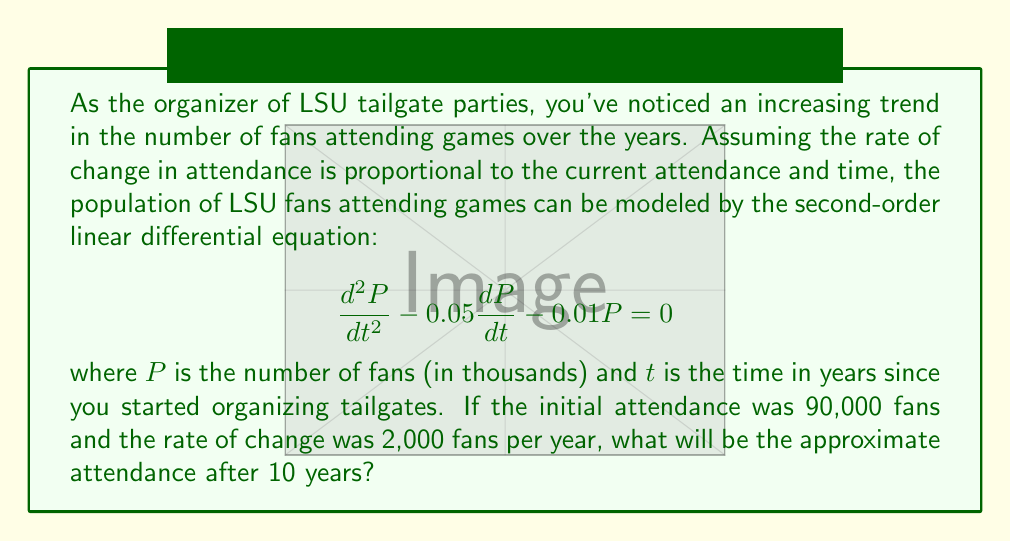Show me your answer to this math problem. To solve this problem, we need to follow these steps:

1) The general solution for this second-order linear differential equation is:

   $$P(t) = C_1e^{r_1t} + C_2e^{r_2t}$$

   where $r_1$ and $r_2$ are the roots of the characteristic equation.

2) The characteristic equation is:
   
   $$r^2 - 0.05r - 0.01 = 0$$

3) Solving this quadratic equation:
   
   $$r = \frac{0.05 \pm \sqrt{0.0025 + 0.04}}{2} = \frac{0.05 \pm 0.2}{2}$$

   $$r_1 = 0.125 \text{ and } r_2 = -0.075$$

4) Therefore, the general solution is:

   $$P(t) = C_1e^{0.125t} + C_2e^{-0.075t}$$

5) Now we use the initial conditions to find $C_1$ and $C_2$:
   
   At $t=0$, $P(0) = 90$ (remember, $P$ is in thousands)
   $$90 = C_1 + C_2$$

   At $t=0$, $P'(0) = 2$ (rate of change is 2,000 fans per year)
   $$2 = 0.125C_1 - 0.075C_2$$

6) Solving these simultaneous equations:
   
   $C_1 \approx 72.4$ and $C_2 \approx 17.6$

7) The particular solution is:

   $$P(t) = 72.4e^{0.125t} + 17.6e^{-0.075t}$$

8) To find the attendance after 10 years, we calculate $P(10)$:

   $$P(10) = 72.4e^{1.25} + 17.6e^{-0.75} \approx 253.7$$

9) Converting back to actual number of fans:

   $253.7 * 1000 = 253,700$ fans
Answer: Approximately 253,700 fans will be attending LSU games after 10 years. 